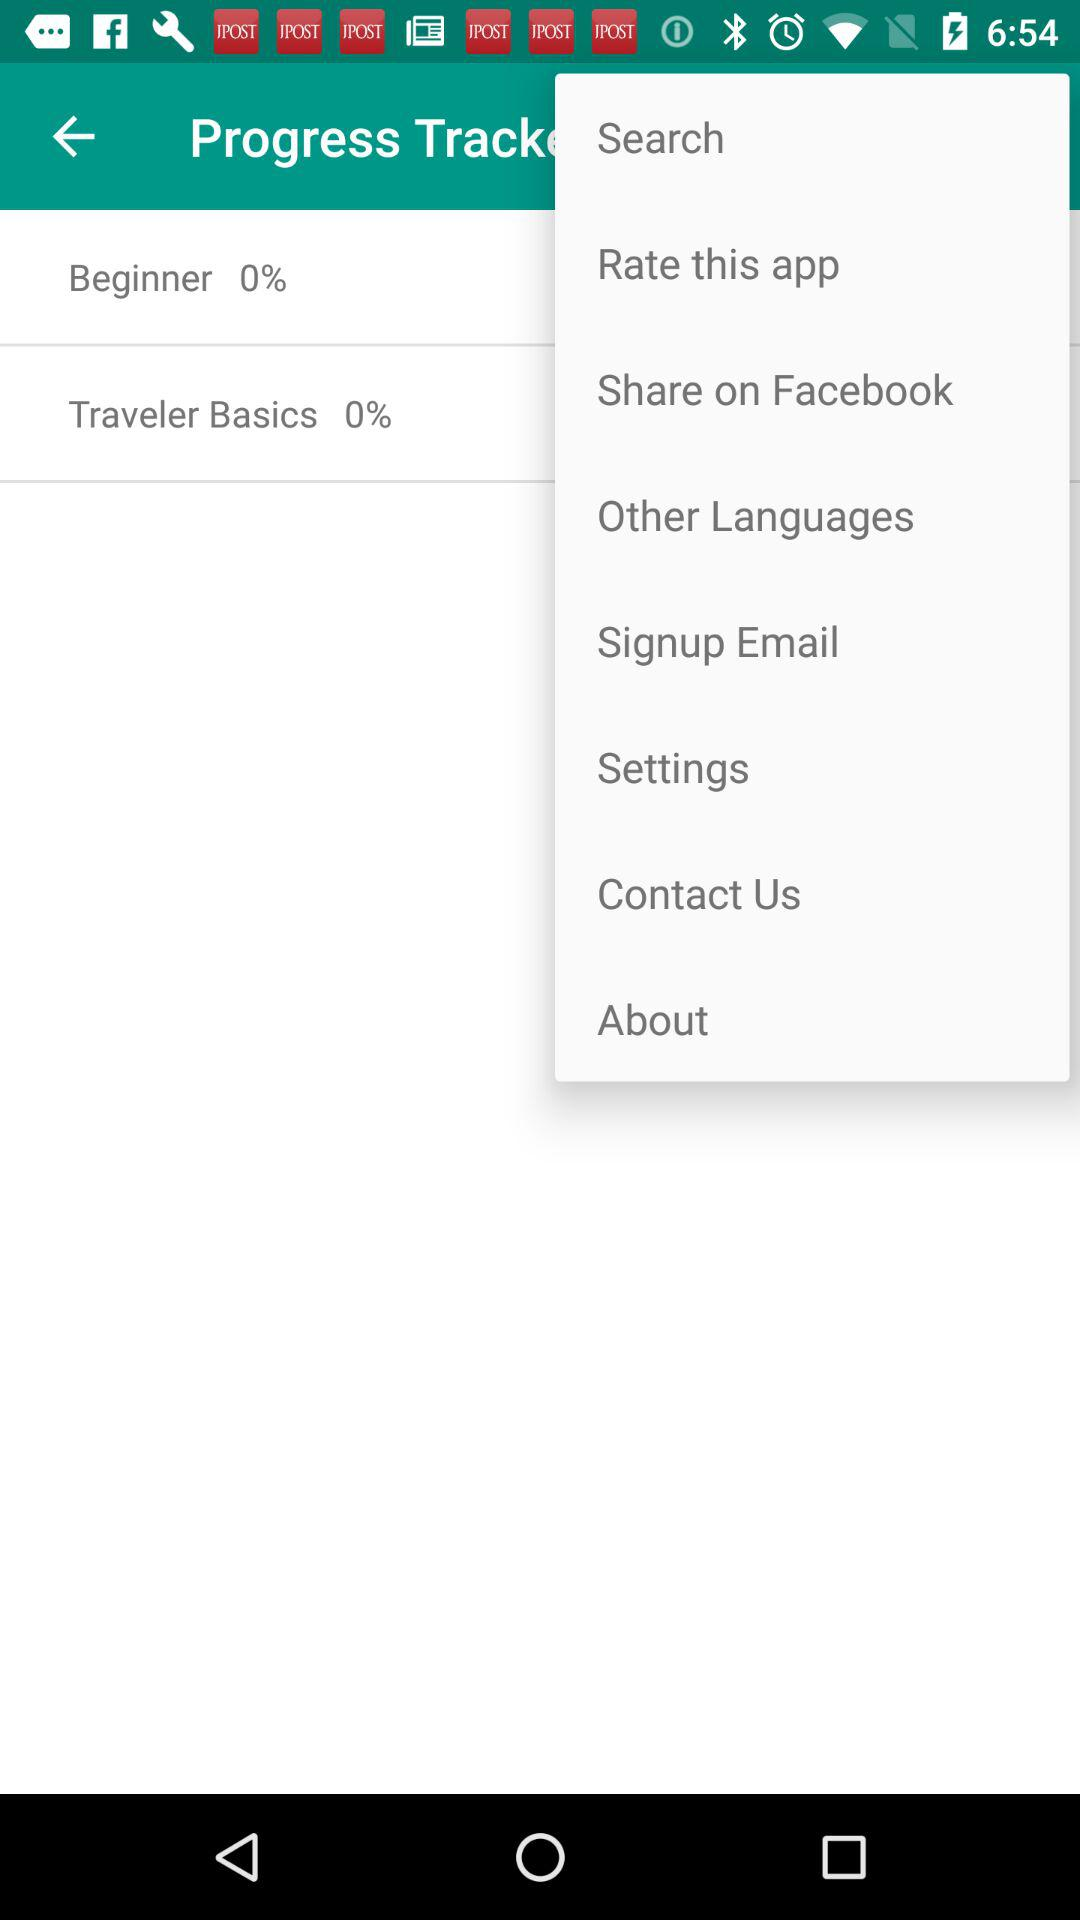What's the "Traveler Basics" percentage? The "Traveler Basics" percentage is 0. 